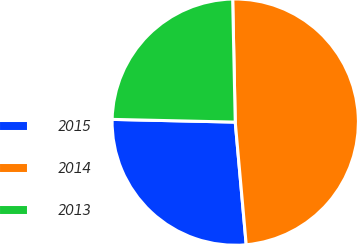Convert chart to OTSL. <chart><loc_0><loc_0><loc_500><loc_500><pie_chart><fcel>2015<fcel>2014<fcel>2013<nl><fcel>26.77%<fcel>48.91%<fcel>24.31%<nl></chart> 